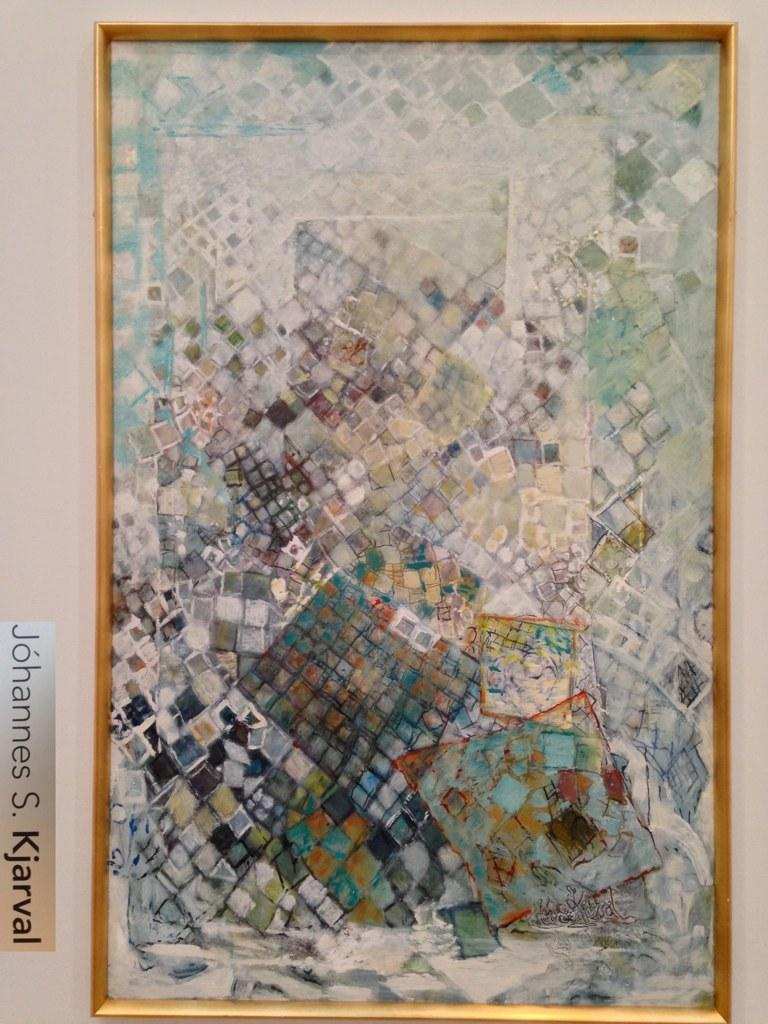<image>
Describe the image concisely. A framed piece of artwork by Johannes S. Kjarval handing on a white wall. 